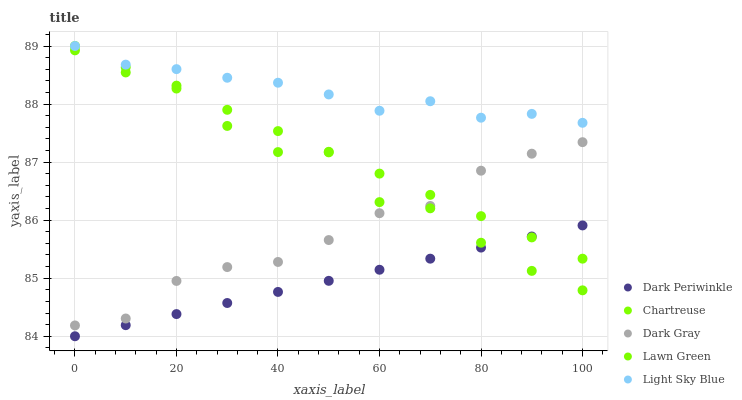Does Dark Periwinkle have the minimum area under the curve?
Answer yes or no. Yes. Does Light Sky Blue have the maximum area under the curve?
Answer yes or no. Yes. Does Lawn Green have the minimum area under the curve?
Answer yes or no. No. Does Lawn Green have the maximum area under the curve?
Answer yes or no. No. Is Chartreuse the smoothest?
Answer yes or no. Yes. Is Lawn Green the roughest?
Answer yes or no. Yes. Is Lawn Green the smoothest?
Answer yes or no. No. Is Chartreuse the roughest?
Answer yes or no. No. Does Dark Periwinkle have the lowest value?
Answer yes or no. Yes. Does Lawn Green have the lowest value?
Answer yes or no. No. Does Light Sky Blue have the highest value?
Answer yes or no. Yes. Does Lawn Green have the highest value?
Answer yes or no. No. Is Dark Gray less than Light Sky Blue?
Answer yes or no. Yes. Is Light Sky Blue greater than Lawn Green?
Answer yes or no. Yes. Does Light Sky Blue intersect Chartreuse?
Answer yes or no. Yes. Is Light Sky Blue less than Chartreuse?
Answer yes or no. No. Is Light Sky Blue greater than Chartreuse?
Answer yes or no. No. Does Dark Gray intersect Light Sky Blue?
Answer yes or no. No. 